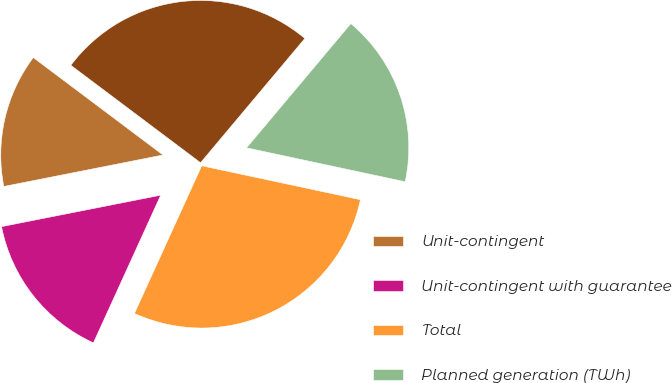Convert chart to OTSL. <chart><loc_0><loc_0><loc_500><loc_500><pie_chart><fcel>Unit-contingent<fcel>Unit-contingent with guarantee<fcel>Total<fcel>Planned generation (TWh)<fcel>Average contracted price per<nl><fcel>13.36%<fcel>15.09%<fcel>28.45%<fcel>17.24%<fcel>25.86%<nl></chart> 